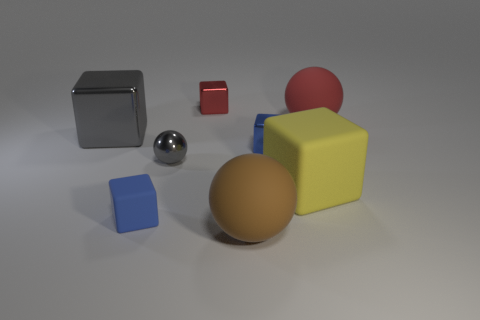What is the shape of the large metal object that is the same color as the small ball?
Keep it short and to the point. Cube. Are there any gray metallic things of the same size as the brown matte ball?
Your answer should be compact. Yes. Is the number of blue blocks in front of the small gray metallic ball less than the number of small red metallic blocks?
Ensure brevity in your answer.  No. Is the number of large brown things that are in front of the big brown thing less than the number of cubes in front of the big yellow cube?
Your response must be concise. Yes. How many spheres are gray objects or yellow things?
Keep it short and to the point. 1. Is the sphere that is in front of the large yellow thing made of the same material as the red object on the right side of the yellow rubber thing?
Make the answer very short. Yes. There is a red object that is the same size as the blue metallic cube; what shape is it?
Offer a very short reply. Cube. How many other objects are the same color as the small rubber block?
Offer a very short reply. 1. How many brown objects are large blocks or tiny balls?
Give a very brief answer. 0. Is the shape of the large matte thing behind the tiny sphere the same as the tiny shiny object that is behind the red matte object?
Provide a succinct answer. No. 